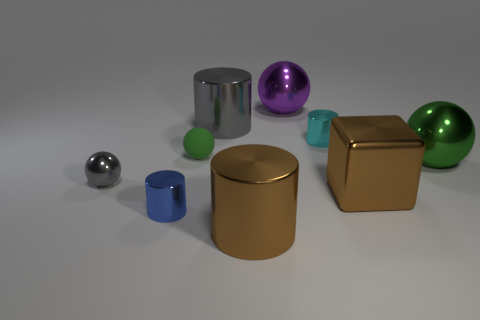Is there anything else that is made of the same material as the small green sphere?
Your response must be concise. No. How many objects are both behind the blue metallic cylinder and on the left side of the green rubber sphere?
Your response must be concise. 1. Are there any large cylinders that are behind the brown metallic object to the left of the cylinder to the right of the purple object?
Offer a terse response. Yes. The purple shiny object that is the same size as the metal block is what shape?
Your response must be concise. Sphere. Is there a tiny cube that has the same color as the tiny rubber thing?
Your response must be concise. No. Is the shape of the big purple metallic thing the same as the tiny rubber object?
Keep it short and to the point. Yes. How many small things are spheres or metal cylinders?
Give a very brief answer. 4. There is a tiny sphere that is the same material as the gray cylinder; what color is it?
Offer a terse response. Gray. How many small green balls have the same material as the large cube?
Your response must be concise. 0. Does the brown shiny thing that is in front of the blue object have the same size as the thing behind the big gray object?
Your answer should be very brief. Yes. 